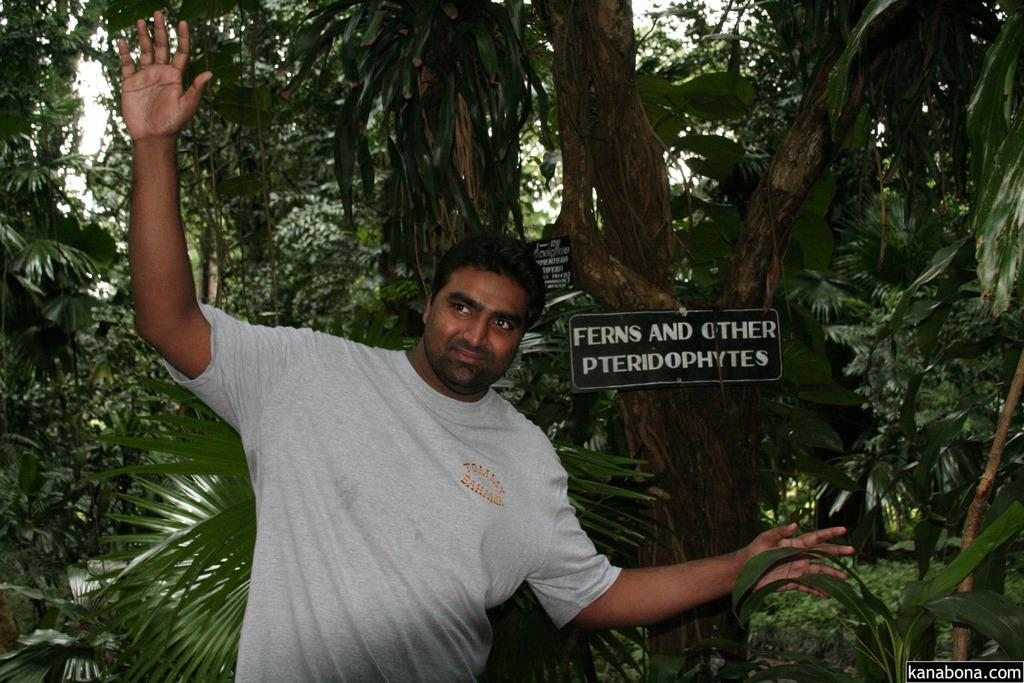What is the main subject of the image? There is a man standing in the image. Where is the man standing? The man is standing on the ground. What can be seen in the background of the image? There are trees in the image. What type of signage is present in the image? There are information boards in the image. What is visible above the ground and trees in the image? The sky is visible in the image. Can you see a fight between the man and a servant in the image? There is no fight or servant present in the image; it only features a man standing on the ground with trees, information boards, and the sky visible in the background. 